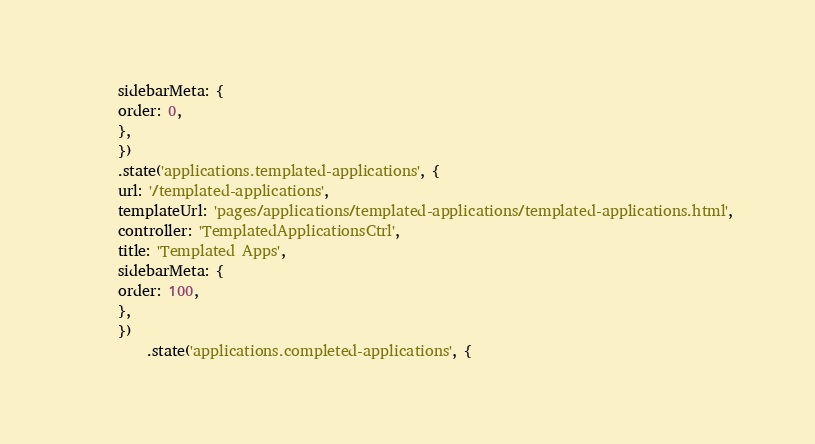Convert code to text. <code><loc_0><loc_0><loc_500><loc_500><_JavaScript_>     sidebarMeta: {
     order: 0,
     },
     })
     .state('applications.templated-applications', {
     url: '/templated-applications',
     templateUrl: 'pages/applications/templated-applications/templated-applications.html',
     controller: 'TemplatedApplicationsCtrl',
     title: 'Templated Apps',
     sidebarMeta: {
     order: 100,
     },
     })
         .state('applications.completed-applications', {</code> 